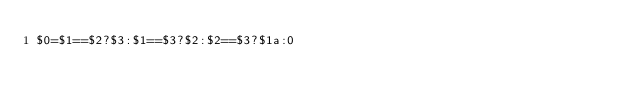<code> <loc_0><loc_0><loc_500><loc_500><_Awk_>$0=$1==$2?$3:$1==$3?$2:$2==$3?$1a:0</code> 